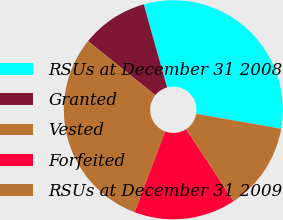Convert chart to OTSL. <chart><loc_0><loc_0><loc_500><loc_500><pie_chart><fcel>RSUs at December 31 2008<fcel>Granted<fcel>Vested<fcel>Forfeited<fcel>RSUs at December 31 2009<nl><fcel>32.13%<fcel>9.86%<fcel>30.04%<fcel>15.03%<fcel>12.94%<nl></chart> 